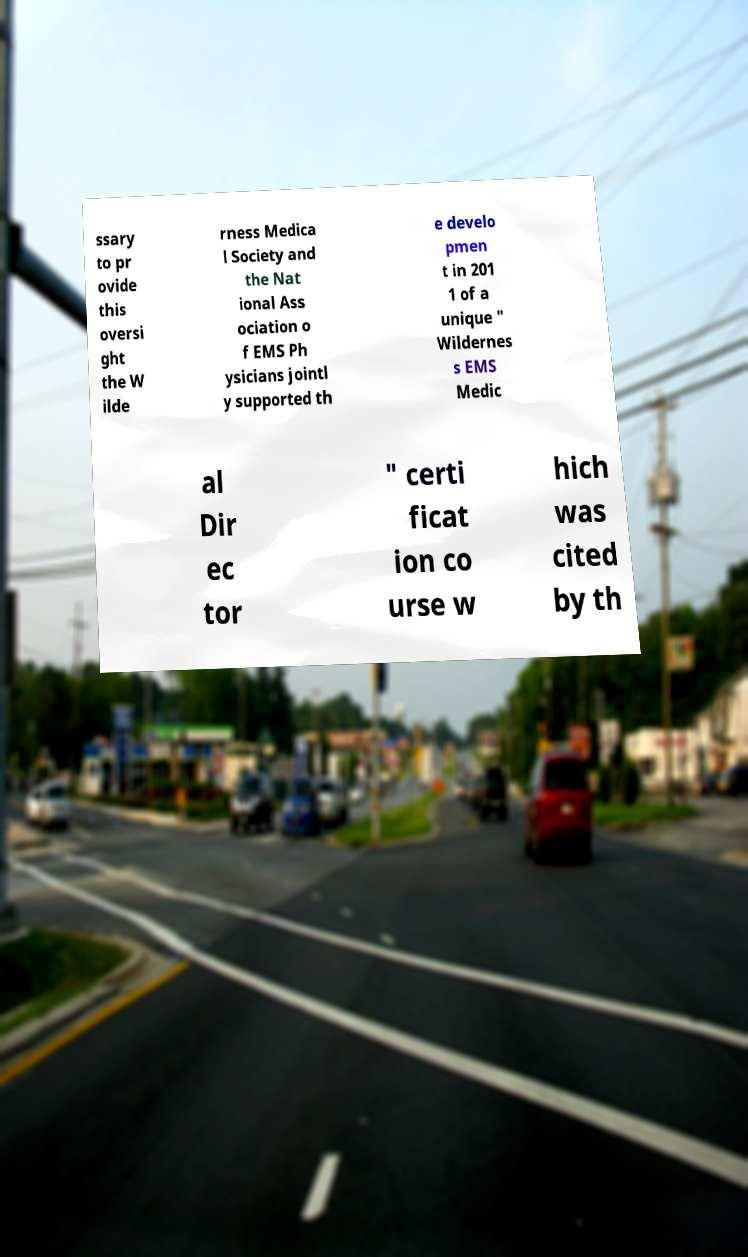There's text embedded in this image that I need extracted. Can you transcribe it verbatim? ssary to pr ovide this oversi ght the W ilde rness Medica l Society and the Nat ional Ass ociation o f EMS Ph ysicians jointl y supported th e develo pmen t in 201 1 of a unique " Wildernes s EMS Medic al Dir ec tor " certi ficat ion co urse w hich was cited by th 